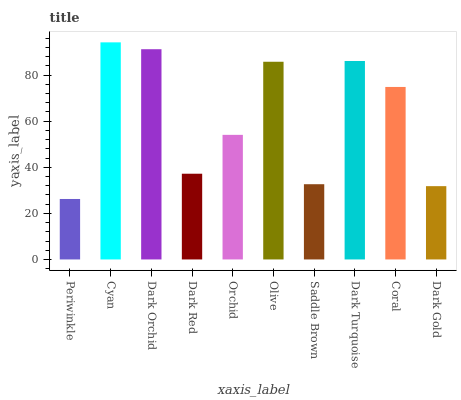Is Dark Orchid the minimum?
Answer yes or no. No. Is Dark Orchid the maximum?
Answer yes or no. No. Is Cyan greater than Dark Orchid?
Answer yes or no. Yes. Is Dark Orchid less than Cyan?
Answer yes or no. Yes. Is Dark Orchid greater than Cyan?
Answer yes or no. No. Is Cyan less than Dark Orchid?
Answer yes or no. No. Is Coral the high median?
Answer yes or no. Yes. Is Orchid the low median?
Answer yes or no. Yes. Is Dark Red the high median?
Answer yes or no. No. Is Dark Gold the low median?
Answer yes or no. No. 